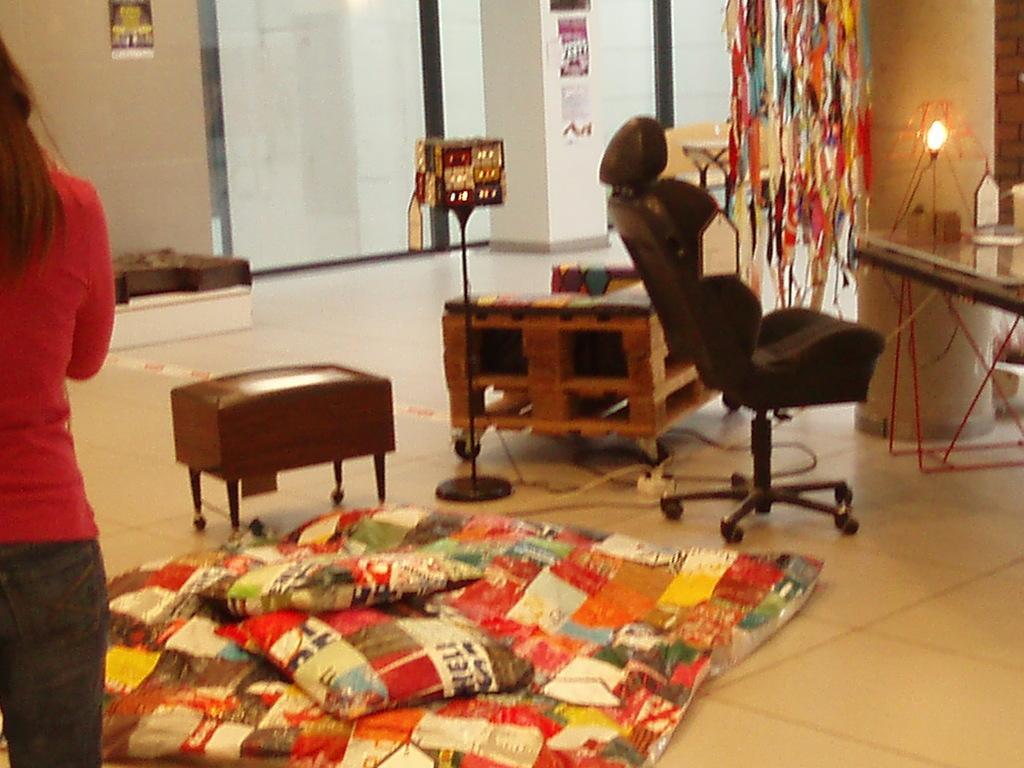Could you give a brief overview of what you see in this image? A woman is standing on the left side. On the floor there is a sheet, two pillows, table, a stand, a chair is over there. On the right side there is a table. On the table there is a table lamp. There are curtains and a wall in the background. 